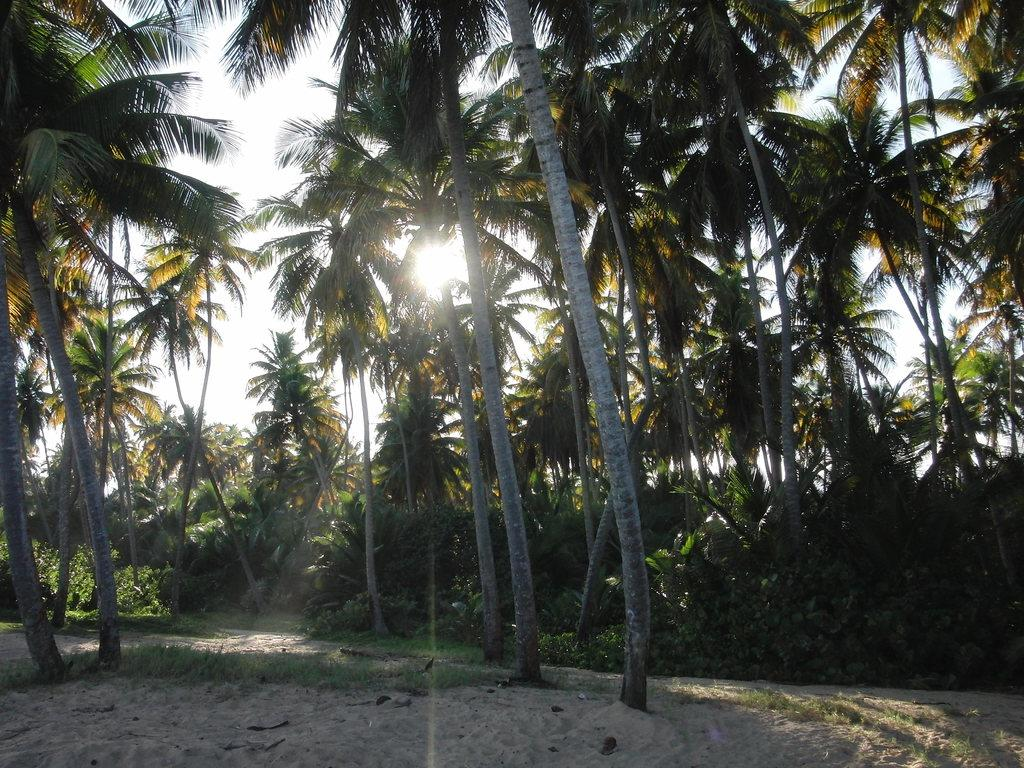What type of terrain is visible in the image? There is sand and grass on the ground in the image. What can be seen in the background of the image? There are trees and the sky visible in the background of the image. What type of powder is being used to clean the underwear in the image? There is no underwear or powder present in the image. 